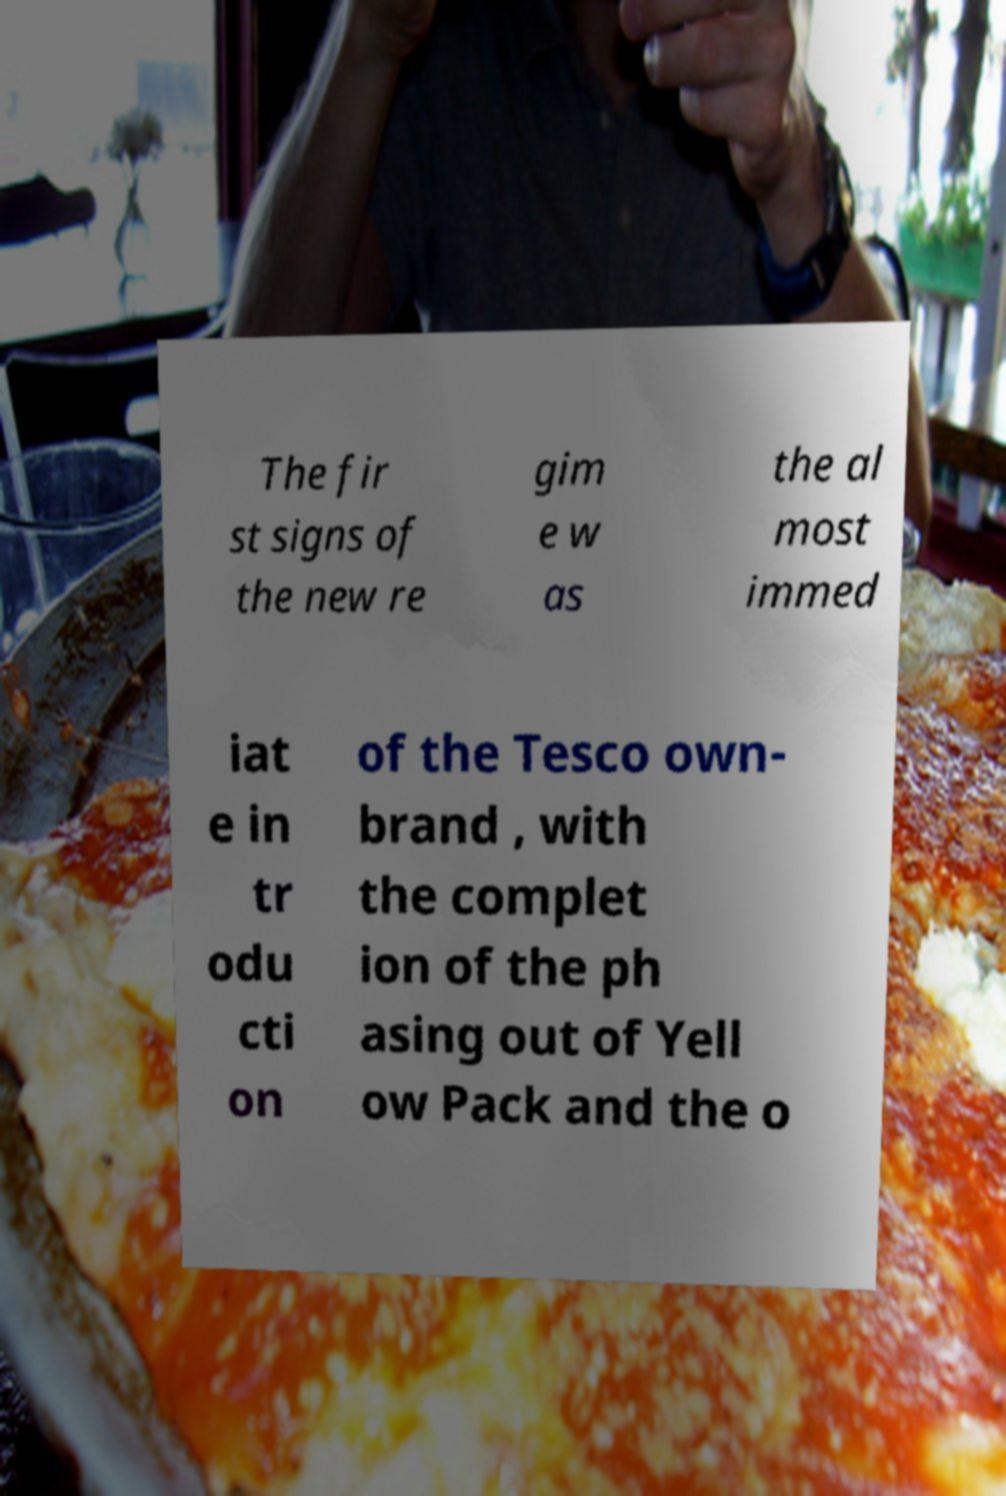For documentation purposes, I need the text within this image transcribed. Could you provide that? The fir st signs of the new re gim e w as the al most immed iat e in tr odu cti on of the Tesco own- brand , with the complet ion of the ph asing out of Yell ow Pack and the o 